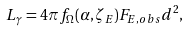<formula> <loc_0><loc_0><loc_500><loc_500>L _ { \gamma } = 4 \pi f _ { \Omega } ( \alpha , \zeta _ { E } ) F _ { E , o b s } d ^ { 2 } ,</formula> 